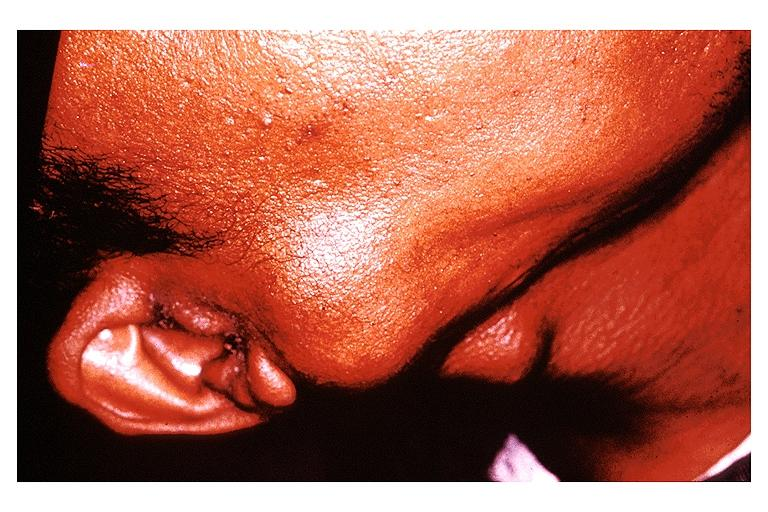does anencephaly show pleomorphic adenoma benign mixed tumor?
Answer the question using a single word or phrase. No 